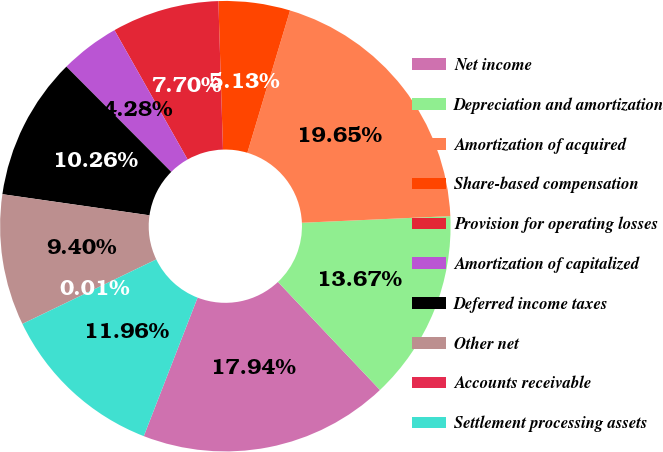<chart> <loc_0><loc_0><loc_500><loc_500><pie_chart><fcel>Net income<fcel>Depreciation and amortization<fcel>Amortization of acquired<fcel>Share-based compensation<fcel>Provision for operating losses<fcel>Amortization of capitalized<fcel>Deferred income taxes<fcel>Other net<fcel>Accounts receivable<fcel>Settlement processing assets<nl><fcel>17.94%<fcel>13.67%<fcel>19.65%<fcel>5.13%<fcel>7.7%<fcel>4.28%<fcel>10.26%<fcel>9.4%<fcel>0.01%<fcel>11.96%<nl></chart> 